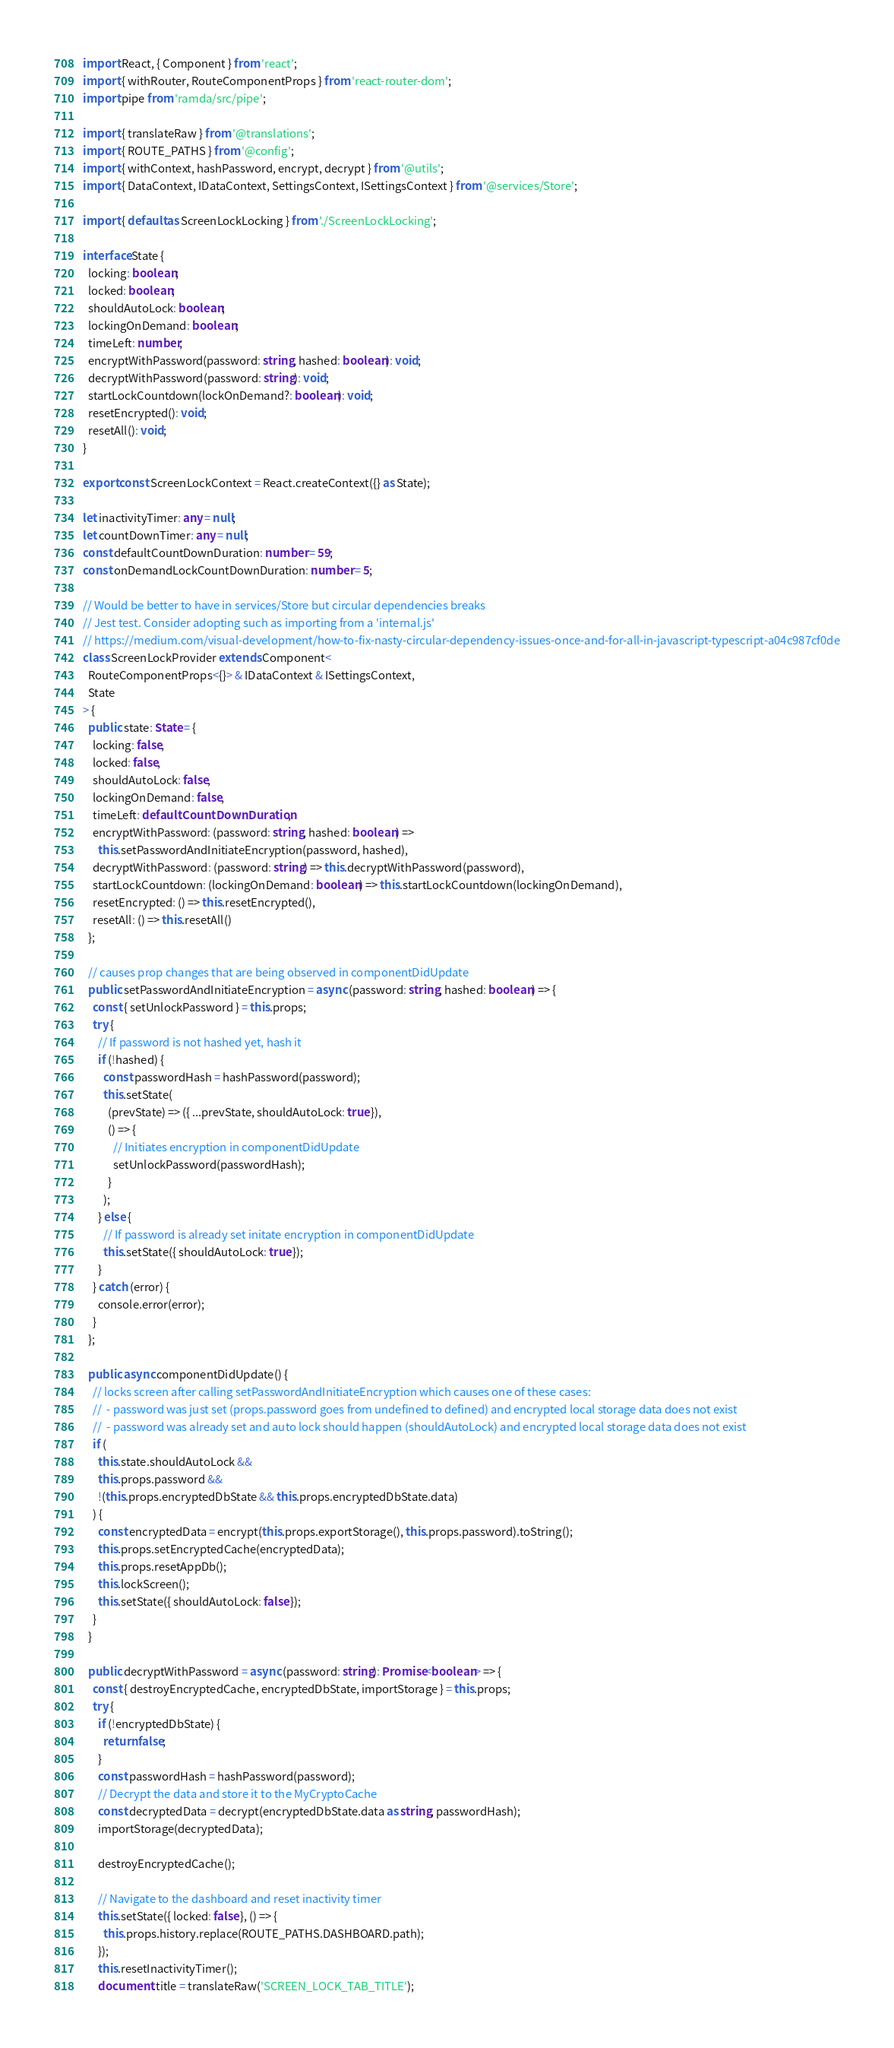Convert code to text. <code><loc_0><loc_0><loc_500><loc_500><_TypeScript_>import React, { Component } from 'react';
import { withRouter, RouteComponentProps } from 'react-router-dom';
import pipe from 'ramda/src/pipe';

import { translateRaw } from '@translations';
import { ROUTE_PATHS } from '@config';
import { withContext, hashPassword, encrypt, decrypt } from '@utils';
import { DataContext, IDataContext, SettingsContext, ISettingsContext } from '@services/Store';

import { default as ScreenLockLocking } from './ScreenLockLocking';

interface State {
  locking: boolean;
  locked: boolean;
  shouldAutoLock: boolean;
  lockingOnDemand: boolean;
  timeLeft: number;
  encryptWithPassword(password: string, hashed: boolean): void;
  decryptWithPassword(password: string): void;
  startLockCountdown(lockOnDemand?: boolean): void;
  resetEncrypted(): void;
  resetAll(): void;
}

export const ScreenLockContext = React.createContext({} as State);

let inactivityTimer: any = null;
let countDownTimer: any = null;
const defaultCountDownDuration: number = 59;
const onDemandLockCountDownDuration: number = 5;

// Would be better to have in services/Store but circular dependencies breaks
// Jest test. Consider adopting such as importing from a 'internal.js'
// https://medium.com/visual-development/how-to-fix-nasty-circular-dependency-issues-once-and-for-all-in-javascript-typescript-a04c987cf0de
class ScreenLockProvider extends Component<
  RouteComponentProps<{}> & IDataContext & ISettingsContext,
  State
> {
  public state: State = {
    locking: false,
    locked: false,
    shouldAutoLock: false,
    lockingOnDemand: false,
    timeLeft: defaultCountDownDuration,
    encryptWithPassword: (password: string, hashed: boolean) =>
      this.setPasswordAndInitiateEncryption(password, hashed),
    decryptWithPassword: (password: string) => this.decryptWithPassword(password),
    startLockCountdown: (lockingOnDemand: boolean) => this.startLockCountdown(lockingOnDemand),
    resetEncrypted: () => this.resetEncrypted(),
    resetAll: () => this.resetAll()
  };

  // causes prop changes that are being observed in componentDidUpdate
  public setPasswordAndInitiateEncryption = async (password: string, hashed: boolean) => {
    const { setUnlockPassword } = this.props;
    try {
      // If password is not hashed yet, hash it
      if (!hashed) {
        const passwordHash = hashPassword(password);
        this.setState(
          (prevState) => ({ ...prevState, shouldAutoLock: true }),
          () => {
            // Initiates encryption in componentDidUpdate
            setUnlockPassword(passwordHash);
          }
        );
      } else {
        // If password is already set initate encryption in componentDidUpdate
        this.setState({ shouldAutoLock: true });
      }
    } catch (error) {
      console.error(error);
    }
  };

  public async componentDidUpdate() {
    // locks screen after calling setPasswordAndInitiateEncryption which causes one of these cases:
    //  - password was just set (props.password goes from undefined to defined) and encrypted local storage data does not exist
    //  - password was already set and auto lock should happen (shouldAutoLock) and encrypted local storage data does not exist
    if (
      this.state.shouldAutoLock &&
      this.props.password &&
      !(this.props.encryptedDbState && this.props.encryptedDbState.data)
    ) {
      const encryptedData = encrypt(this.props.exportStorage(), this.props.password).toString();
      this.props.setEncryptedCache(encryptedData);
      this.props.resetAppDb();
      this.lockScreen();
      this.setState({ shouldAutoLock: false });
    }
  }

  public decryptWithPassword = async (password: string): Promise<boolean> => {
    const { destroyEncryptedCache, encryptedDbState, importStorage } = this.props;
    try {
      if (!encryptedDbState) {
        return false;
      }
      const passwordHash = hashPassword(password);
      // Decrypt the data and store it to the MyCryptoCache
      const decryptedData = decrypt(encryptedDbState.data as string, passwordHash);
      importStorage(decryptedData);

      destroyEncryptedCache();

      // Navigate to the dashboard and reset inactivity timer
      this.setState({ locked: false }, () => {
        this.props.history.replace(ROUTE_PATHS.DASHBOARD.path);
      });
      this.resetInactivityTimer();
      document.title = translateRaw('SCREEN_LOCK_TAB_TITLE');</code> 